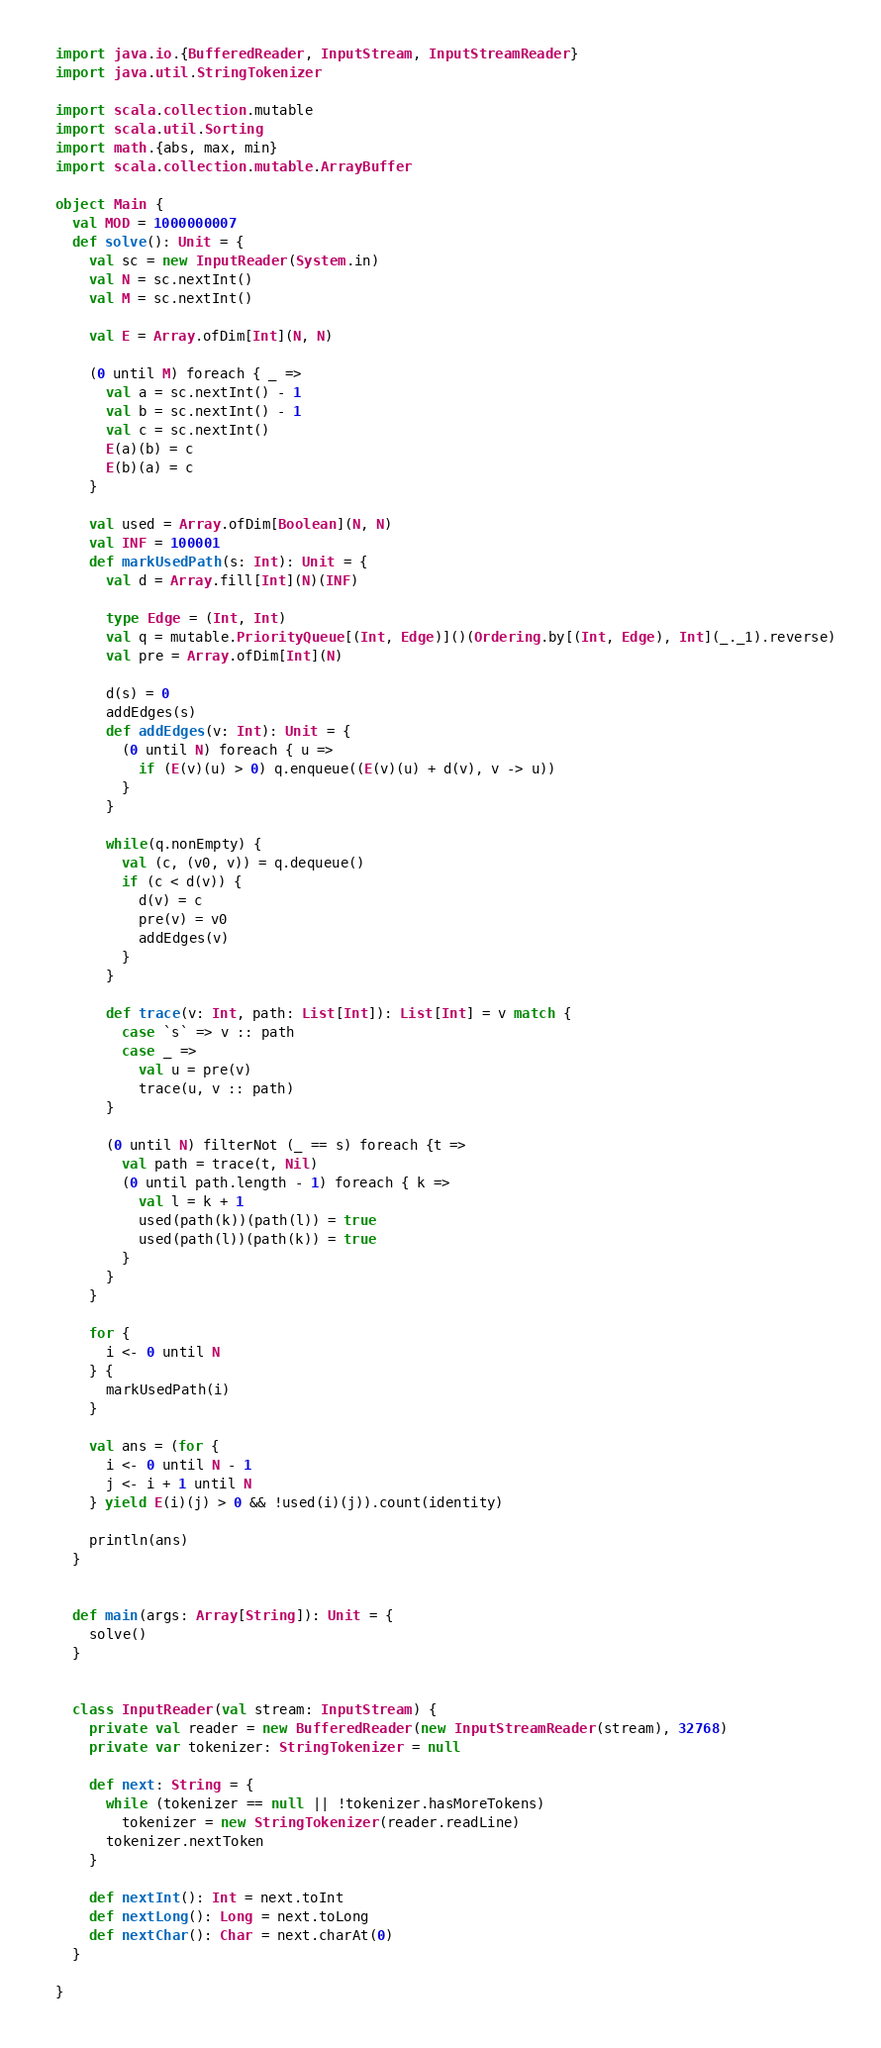<code> <loc_0><loc_0><loc_500><loc_500><_Scala_>import java.io.{BufferedReader, InputStream, InputStreamReader}
import java.util.StringTokenizer

import scala.collection.mutable
import scala.util.Sorting
import math.{abs, max, min}
import scala.collection.mutable.ArrayBuffer

object Main {
  val MOD = 1000000007
  def solve(): Unit = {
    val sc = new InputReader(System.in)
    val N = sc.nextInt()
    val M = sc.nextInt()

    val E = Array.ofDim[Int](N, N)

    (0 until M) foreach { _ =>
      val a = sc.nextInt() - 1
      val b = sc.nextInt() - 1
      val c = sc.nextInt()
      E(a)(b) = c
      E(b)(a) = c
    }

    val used = Array.ofDim[Boolean](N, N)
    val INF = 100001
    def markUsedPath(s: Int): Unit = {
      val d = Array.fill[Int](N)(INF)

      type Edge = (Int, Int)
      val q = mutable.PriorityQueue[(Int, Edge)]()(Ordering.by[(Int, Edge), Int](_._1).reverse)
      val pre = Array.ofDim[Int](N)

      d(s) = 0
      addEdges(s)
      def addEdges(v: Int): Unit = {
        (0 until N) foreach { u =>
          if (E(v)(u) > 0) q.enqueue((E(v)(u) + d(v), v -> u))
        }
      }

      while(q.nonEmpty) {
        val (c, (v0, v)) = q.dequeue()
        if (c < d(v)) {
          d(v) = c
          pre(v) = v0
          addEdges(v)
        }
      }

      def trace(v: Int, path: List[Int]): List[Int] = v match {
        case `s` => v :: path
        case _ =>
          val u = pre(v)
          trace(u, v :: path)
      }

      (0 until N) filterNot (_ == s) foreach {t =>
        val path = trace(t, Nil)
        (0 until path.length - 1) foreach { k =>
          val l = k + 1
          used(path(k))(path(l)) = true
          used(path(l))(path(k)) = true
        }
      }
    }

    for {
      i <- 0 until N
    } {
      markUsedPath(i)
    }

    val ans = (for {
      i <- 0 until N - 1
      j <- i + 1 until N
    } yield E(i)(j) > 0 && !used(i)(j)).count(identity)

    println(ans)
  }


  def main(args: Array[String]): Unit = {
    solve()
  }


  class InputReader(val stream: InputStream) {
    private val reader = new BufferedReader(new InputStreamReader(stream), 32768)
    private var tokenizer: StringTokenizer = null

    def next: String = {
      while (tokenizer == null || !tokenizer.hasMoreTokens)
        tokenizer = new StringTokenizer(reader.readLine)
      tokenizer.nextToken
    }

    def nextInt(): Int = next.toInt
    def nextLong(): Long = next.toLong
    def nextChar(): Char = next.charAt(0)
  }

}
</code> 